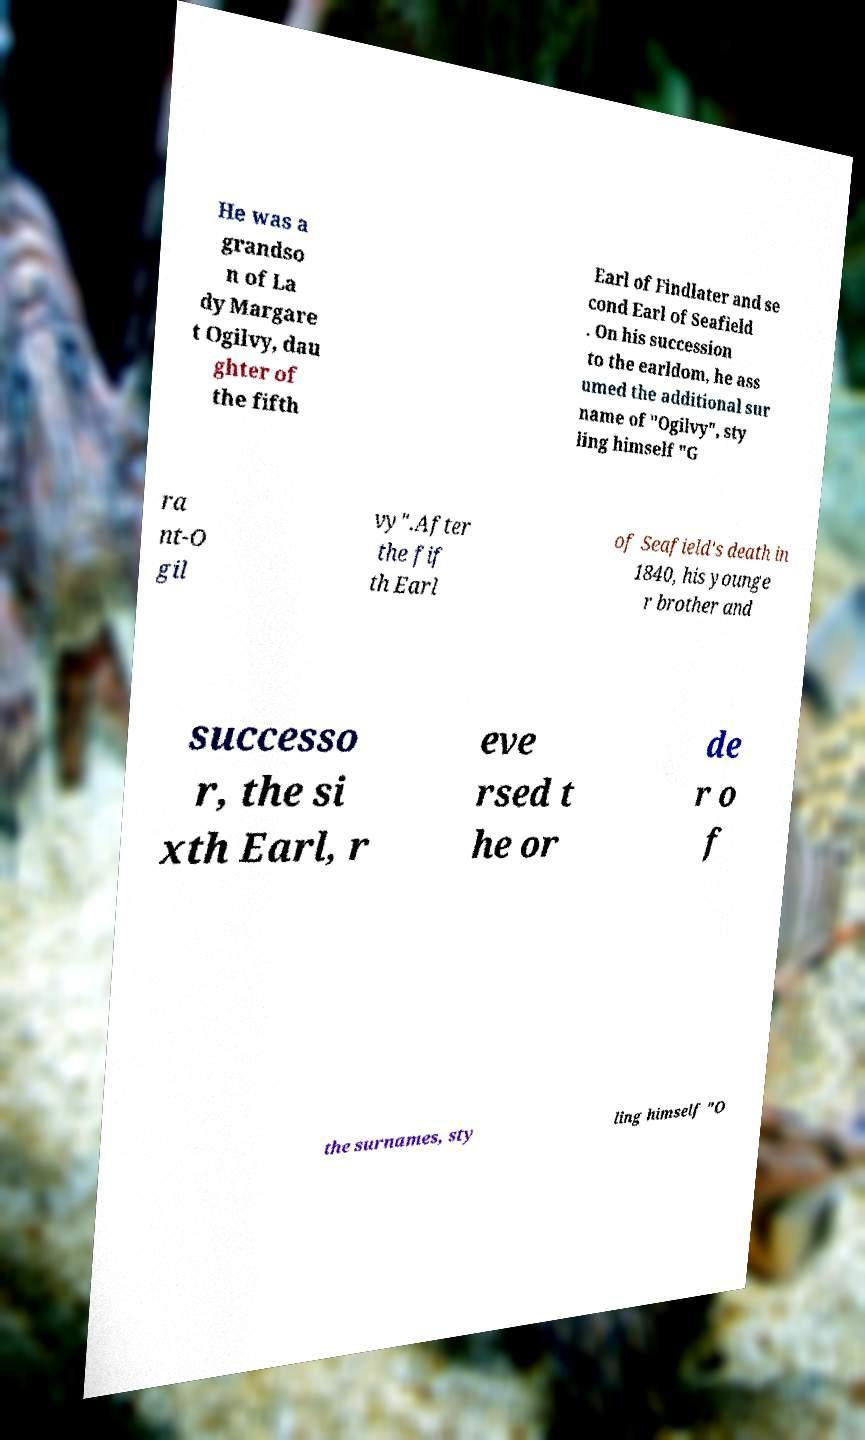What messages or text are displayed in this image? I need them in a readable, typed format. He was a grandso n of La dy Margare t Ogilvy, dau ghter of the fifth Earl of Findlater and se cond Earl of Seafield . On his succession to the earldom, he ass umed the additional sur name of "Ogilvy", sty ling himself "G ra nt-O gil vy".After the fif th Earl of Seafield's death in 1840, his younge r brother and successo r, the si xth Earl, r eve rsed t he or de r o f the surnames, sty ling himself "O 